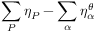<formula> <loc_0><loc_0><loc_500><loc_500>\sum _ { P } \eta _ { P } - \sum _ { \alpha } \eta _ { \alpha } ^ { \theta }</formula> 